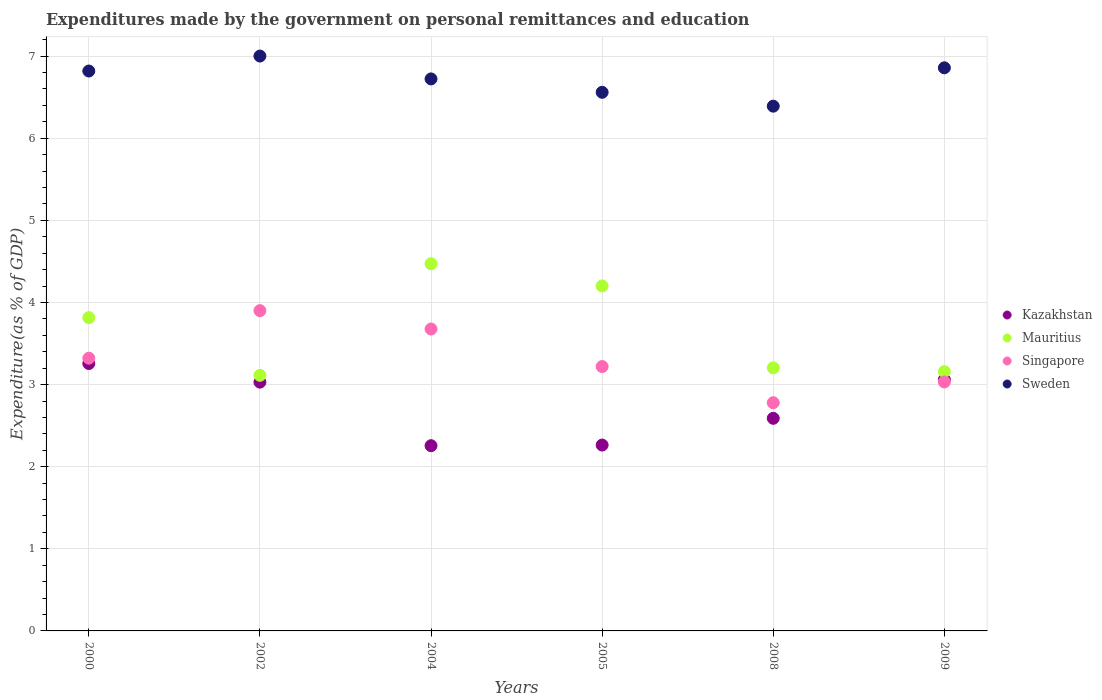What is the expenditures made by the government on personal remittances and education in Singapore in 2008?
Your answer should be compact. 2.78. Across all years, what is the maximum expenditures made by the government on personal remittances and education in Mauritius?
Provide a short and direct response. 4.47. Across all years, what is the minimum expenditures made by the government on personal remittances and education in Mauritius?
Give a very brief answer. 3.11. In which year was the expenditures made by the government on personal remittances and education in Singapore minimum?
Keep it short and to the point. 2008. What is the total expenditures made by the government on personal remittances and education in Mauritius in the graph?
Your answer should be compact. 21.96. What is the difference between the expenditures made by the government on personal remittances and education in Kazakhstan in 2004 and that in 2008?
Your answer should be very brief. -0.33. What is the difference between the expenditures made by the government on personal remittances and education in Kazakhstan in 2004 and the expenditures made by the government on personal remittances and education in Sweden in 2005?
Your answer should be very brief. -4.3. What is the average expenditures made by the government on personal remittances and education in Mauritius per year?
Keep it short and to the point. 3.66. In the year 2005, what is the difference between the expenditures made by the government on personal remittances and education in Singapore and expenditures made by the government on personal remittances and education in Kazakhstan?
Provide a short and direct response. 0.96. What is the ratio of the expenditures made by the government on personal remittances and education in Singapore in 2000 to that in 2009?
Your answer should be very brief. 1.1. What is the difference between the highest and the second highest expenditures made by the government on personal remittances and education in Kazakhstan?
Your answer should be very brief. 0.2. What is the difference between the highest and the lowest expenditures made by the government on personal remittances and education in Singapore?
Your response must be concise. 1.12. Does the expenditures made by the government on personal remittances and education in Singapore monotonically increase over the years?
Provide a succinct answer. No. Is the expenditures made by the government on personal remittances and education in Kazakhstan strictly less than the expenditures made by the government on personal remittances and education in Sweden over the years?
Your answer should be compact. Yes. How many dotlines are there?
Your answer should be very brief. 4. What is the difference between two consecutive major ticks on the Y-axis?
Your answer should be compact. 1. Are the values on the major ticks of Y-axis written in scientific E-notation?
Ensure brevity in your answer.  No. What is the title of the graph?
Provide a short and direct response. Expenditures made by the government on personal remittances and education. Does "Serbia" appear as one of the legend labels in the graph?
Your response must be concise. No. What is the label or title of the X-axis?
Your answer should be compact. Years. What is the label or title of the Y-axis?
Offer a very short reply. Expenditure(as % of GDP). What is the Expenditure(as % of GDP) in Kazakhstan in 2000?
Your answer should be compact. 3.26. What is the Expenditure(as % of GDP) in Mauritius in 2000?
Your response must be concise. 3.82. What is the Expenditure(as % of GDP) in Singapore in 2000?
Give a very brief answer. 3.32. What is the Expenditure(as % of GDP) in Sweden in 2000?
Your response must be concise. 6.82. What is the Expenditure(as % of GDP) in Kazakhstan in 2002?
Offer a terse response. 3.03. What is the Expenditure(as % of GDP) in Mauritius in 2002?
Make the answer very short. 3.11. What is the Expenditure(as % of GDP) in Singapore in 2002?
Offer a terse response. 3.9. What is the Expenditure(as % of GDP) in Sweden in 2002?
Your answer should be compact. 7. What is the Expenditure(as % of GDP) of Kazakhstan in 2004?
Your answer should be compact. 2.26. What is the Expenditure(as % of GDP) in Mauritius in 2004?
Give a very brief answer. 4.47. What is the Expenditure(as % of GDP) of Singapore in 2004?
Offer a very short reply. 3.68. What is the Expenditure(as % of GDP) of Sweden in 2004?
Your answer should be very brief. 6.72. What is the Expenditure(as % of GDP) of Kazakhstan in 2005?
Give a very brief answer. 2.26. What is the Expenditure(as % of GDP) in Mauritius in 2005?
Keep it short and to the point. 4.2. What is the Expenditure(as % of GDP) in Singapore in 2005?
Provide a short and direct response. 3.22. What is the Expenditure(as % of GDP) of Sweden in 2005?
Offer a very short reply. 6.56. What is the Expenditure(as % of GDP) in Kazakhstan in 2008?
Keep it short and to the point. 2.59. What is the Expenditure(as % of GDP) of Mauritius in 2008?
Your response must be concise. 3.2. What is the Expenditure(as % of GDP) in Singapore in 2008?
Your answer should be very brief. 2.78. What is the Expenditure(as % of GDP) of Sweden in 2008?
Provide a succinct answer. 6.39. What is the Expenditure(as % of GDP) of Kazakhstan in 2009?
Offer a very short reply. 3.06. What is the Expenditure(as % of GDP) of Mauritius in 2009?
Make the answer very short. 3.16. What is the Expenditure(as % of GDP) in Singapore in 2009?
Provide a succinct answer. 3.03. What is the Expenditure(as % of GDP) of Sweden in 2009?
Your answer should be compact. 6.86. Across all years, what is the maximum Expenditure(as % of GDP) of Kazakhstan?
Offer a very short reply. 3.26. Across all years, what is the maximum Expenditure(as % of GDP) of Mauritius?
Your response must be concise. 4.47. Across all years, what is the maximum Expenditure(as % of GDP) in Singapore?
Provide a succinct answer. 3.9. Across all years, what is the maximum Expenditure(as % of GDP) of Sweden?
Your answer should be very brief. 7. Across all years, what is the minimum Expenditure(as % of GDP) in Kazakhstan?
Ensure brevity in your answer.  2.26. Across all years, what is the minimum Expenditure(as % of GDP) in Mauritius?
Ensure brevity in your answer.  3.11. Across all years, what is the minimum Expenditure(as % of GDP) of Singapore?
Ensure brevity in your answer.  2.78. Across all years, what is the minimum Expenditure(as % of GDP) in Sweden?
Your answer should be compact. 6.39. What is the total Expenditure(as % of GDP) of Kazakhstan in the graph?
Your answer should be compact. 16.46. What is the total Expenditure(as % of GDP) in Mauritius in the graph?
Offer a very short reply. 21.96. What is the total Expenditure(as % of GDP) of Singapore in the graph?
Your answer should be compact. 19.93. What is the total Expenditure(as % of GDP) of Sweden in the graph?
Provide a succinct answer. 40.35. What is the difference between the Expenditure(as % of GDP) of Kazakhstan in 2000 and that in 2002?
Your answer should be very brief. 0.23. What is the difference between the Expenditure(as % of GDP) in Mauritius in 2000 and that in 2002?
Provide a succinct answer. 0.7. What is the difference between the Expenditure(as % of GDP) in Singapore in 2000 and that in 2002?
Provide a short and direct response. -0.58. What is the difference between the Expenditure(as % of GDP) of Sweden in 2000 and that in 2002?
Keep it short and to the point. -0.18. What is the difference between the Expenditure(as % of GDP) in Kazakhstan in 2000 and that in 2004?
Your answer should be very brief. 1. What is the difference between the Expenditure(as % of GDP) of Mauritius in 2000 and that in 2004?
Give a very brief answer. -0.66. What is the difference between the Expenditure(as % of GDP) of Singapore in 2000 and that in 2004?
Your answer should be very brief. -0.36. What is the difference between the Expenditure(as % of GDP) in Sweden in 2000 and that in 2004?
Your answer should be compact. 0.1. What is the difference between the Expenditure(as % of GDP) in Kazakhstan in 2000 and that in 2005?
Make the answer very short. 0.99. What is the difference between the Expenditure(as % of GDP) of Mauritius in 2000 and that in 2005?
Your response must be concise. -0.39. What is the difference between the Expenditure(as % of GDP) of Singapore in 2000 and that in 2005?
Your response must be concise. 0.1. What is the difference between the Expenditure(as % of GDP) of Sweden in 2000 and that in 2005?
Keep it short and to the point. 0.26. What is the difference between the Expenditure(as % of GDP) in Kazakhstan in 2000 and that in 2008?
Ensure brevity in your answer.  0.67. What is the difference between the Expenditure(as % of GDP) in Mauritius in 2000 and that in 2008?
Ensure brevity in your answer.  0.61. What is the difference between the Expenditure(as % of GDP) of Singapore in 2000 and that in 2008?
Offer a terse response. 0.54. What is the difference between the Expenditure(as % of GDP) of Sweden in 2000 and that in 2008?
Make the answer very short. 0.43. What is the difference between the Expenditure(as % of GDP) of Kazakhstan in 2000 and that in 2009?
Your answer should be very brief. 0.2. What is the difference between the Expenditure(as % of GDP) of Mauritius in 2000 and that in 2009?
Your answer should be very brief. 0.66. What is the difference between the Expenditure(as % of GDP) of Singapore in 2000 and that in 2009?
Provide a succinct answer. 0.29. What is the difference between the Expenditure(as % of GDP) in Sweden in 2000 and that in 2009?
Ensure brevity in your answer.  -0.04. What is the difference between the Expenditure(as % of GDP) in Kazakhstan in 2002 and that in 2004?
Your response must be concise. 0.77. What is the difference between the Expenditure(as % of GDP) in Mauritius in 2002 and that in 2004?
Provide a succinct answer. -1.36. What is the difference between the Expenditure(as % of GDP) in Singapore in 2002 and that in 2004?
Your answer should be compact. 0.22. What is the difference between the Expenditure(as % of GDP) in Sweden in 2002 and that in 2004?
Offer a terse response. 0.28. What is the difference between the Expenditure(as % of GDP) in Kazakhstan in 2002 and that in 2005?
Make the answer very short. 0.77. What is the difference between the Expenditure(as % of GDP) of Mauritius in 2002 and that in 2005?
Provide a succinct answer. -1.09. What is the difference between the Expenditure(as % of GDP) in Singapore in 2002 and that in 2005?
Your answer should be compact. 0.68. What is the difference between the Expenditure(as % of GDP) in Sweden in 2002 and that in 2005?
Make the answer very short. 0.44. What is the difference between the Expenditure(as % of GDP) of Kazakhstan in 2002 and that in 2008?
Make the answer very short. 0.44. What is the difference between the Expenditure(as % of GDP) of Mauritius in 2002 and that in 2008?
Your response must be concise. -0.09. What is the difference between the Expenditure(as % of GDP) in Singapore in 2002 and that in 2008?
Your answer should be compact. 1.12. What is the difference between the Expenditure(as % of GDP) of Sweden in 2002 and that in 2008?
Your answer should be very brief. 0.61. What is the difference between the Expenditure(as % of GDP) of Kazakhstan in 2002 and that in 2009?
Provide a succinct answer. -0.03. What is the difference between the Expenditure(as % of GDP) in Mauritius in 2002 and that in 2009?
Provide a short and direct response. -0.04. What is the difference between the Expenditure(as % of GDP) in Singapore in 2002 and that in 2009?
Provide a succinct answer. 0.87. What is the difference between the Expenditure(as % of GDP) in Sweden in 2002 and that in 2009?
Provide a succinct answer. 0.14. What is the difference between the Expenditure(as % of GDP) in Kazakhstan in 2004 and that in 2005?
Offer a terse response. -0.01. What is the difference between the Expenditure(as % of GDP) in Mauritius in 2004 and that in 2005?
Keep it short and to the point. 0.27. What is the difference between the Expenditure(as % of GDP) of Singapore in 2004 and that in 2005?
Keep it short and to the point. 0.46. What is the difference between the Expenditure(as % of GDP) of Sweden in 2004 and that in 2005?
Provide a short and direct response. 0.16. What is the difference between the Expenditure(as % of GDP) in Kazakhstan in 2004 and that in 2008?
Offer a very short reply. -0.33. What is the difference between the Expenditure(as % of GDP) of Mauritius in 2004 and that in 2008?
Provide a succinct answer. 1.27. What is the difference between the Expenditure(as % of GDP) of Singapore in 2004 and that in 2008?
Keep it short and to the point. 0.9. What is the difference between the Expenditure(as % of GDP) in Sweden in 2004 and that in 2008?
Give a very brief answer. 0.33. What is the difference between the Expenditure(as % of GDP) of Kazakhstan in 2004 and that in 2009?
Provide a succinct answer. -0.8. What is the difference between the Expenditure(as % of GDP) in Mauritius in 2004 and that in 2009?
Your answer should be compact. 1.31. What is the difference between the Expenditure(as % of GDP) of Singapore in 2004 and that in 2009?
Your answer should be very brief. 0.65. What is the difference between the Expenditure(as % of GDP) of Sweden in 2004 and that in 2009?
Your response must be concise. -0.14. What is the difference between the Expenditure(as % of GDP) of Kazakhstan in 2005 and that in 2008?
Offer a very short reply. -0.33. What is the difference between the Expenditure(as % of GDP) in Singapore in 2005 and that in 2008?
Keep it short and to the point. 0.44. What is the difference between the Expenditure(as % of GDP) of Sweden in 2005 and that in 2008?
Offer a very short reply. 0.17. What is the difference between the Expenditure(as % of GDP) of Kazakhstan in 2005 and that in 2009?
Your answer should be very brief. -0.8. What is the difference between the Expenditure(as % of GDP) of Mauritius in 2005 and that in 2009?
Ensure brevity in your answer.  1.04. What is the difference between the Expenditure(as % of GDP) of Singapore in 2005 and that in 2009?
Provide a short and direct response. 0.19. What is the difference between the Expenditure(as % of GDP) of Sweden in 2005 and that in 2009?
Provide a short and direct response. -0.3. What is the difference between the Expenditure(as % of GDP) in Kazakhstan in 2008 and that in 2009?
Your response must be concise. -0.47. What is the difference between the Expenditure(as % of GDP) in Mauritius in 2008 and that in 2009?
Your answer should be very brief. 0.05. What is the difference between the Expenditure(as % of GDP) in Singapore in 2008 and that in 2009?
Make the answer very short. -0.25. What is the difference between the Expenditure(as % of GDP) in Sweden in 2008 and that in 2009?
Offer a very short reply. -0.47. What is the difference between the Expenditure(as % of GDP) in Kazakhstan in 2000 and the Expenditure(as % of GDP) in Mauritius in 2002?
Offer a terse response. 0.14. What is the difference between the Expenditure(as % of GDP) of Kazakhstan in 2000 and the Expenditure(as % of GDP) of Singapore in 2002?
Offer a very short reply. -0.64. What is the difference between the Expenditure(as % of GDP) in Kazakhstan in 2000 and the Expenditure(as % of GDP) in Sweden in 2002?
Your answer should be very brief. -3.74. What is the difference between the Expenditure(as % of GDP) of Mauritius in 2000 and the Expenditure(as % of GDP) of Singapore in 2002?
Your response must be concise. -0.09. What is the difference between the Expenditure(as % of GDP) of Mauritius in 2000 and the Expenditure(as % of GDP) of Sweden in 2002?
Provide a succinct answer. -3.19. What is the difference between the Expenditure(as % of GDP) in Singapore in 2000 and the Expenditure(as % of GDP) in Sweden in 2002?
Ensure brevity in your answer.  -3.68. What is the difference between the Expenditure(as % of GDP) of Kazakhstan in 2000 and the Expenditure(as % of GDP) of Mauritius in 2004?
Provide a succinct answer. -1.22. What is the difference between the Expenditure(as % of GDP) in Kazakhstan in 2000 and the Expenditure(as % of GDP) in Singapore in 2004?
Your response must be concise. -0.42. What is the difference between the Expenditure(as % of GDP) of Kazakhstan in 2000 and the Expenditure(as % of GDP) of Sweden in 2004?
Provide a succinct answer. -3.47. What is the difference between the Expenditure(as % of GDP) of Mauritius in 2000 and the Expenditure(as % of GDP) of Singapore in 2004?
Offer a very short reply. 0.14. What is the difference between the Expenditure(as % of GDP) of Mauritius in 2000 and the Expenditure(as % of GDP) of Sweden in 2004?
Your response must be concise. -2.91. What is the difference between the Expenditure(as % of GDP) of Singapore in 2000 and the Expenditure(as % of GDP) of Sweden in 2004?
Give a very brief answer. -3.4. What is the difference between the Expenditure(as % of GDP) of Kazakhstan in 2000 and the Expenditure(as % of GDP) of Mauritius in 2005?
Your answer should be very brief. -0.94. What is the difference between the Expenditure(as % of GDP) in Kazakhstan in 2000 and the Expenditure(as % of GDP) in Singapore in 2005?
Your answer should be very brief. 0.04. What is the difference between the Expenditure(as % of GDP) of Kazakhstan in 2000 and the Expenditure(as % of GDP) of Sweden in 2005?
Keep it short and to the point. -3.3. What is the difference between the Expenditure(as % of GDP) of Mauritius in 2000 and the Expenditure(as % of GDP) of Singapore in 2005?
Provide a short and direct response. 0.6. What is the difference between the Expenditure(as % of GDP) in Mauritius in 2000 and the Expenditure(as % of GDP) in Sweden in 2005?
Keep it short and to the point. -2.74. What is the difference between the Expenditure(as % of GDP) of Singapore in 2000 and the Expenditure(as % of GDP) of Sweden in 2005?
Make the answer very short. -3.24. What is the difference between the Expenditure(as % of GDP) of Kazakhstan in 2000 and the Expenditure(as % of GDP) of Mauritius in 2008?
Provide a short and direct response. 0.05. What is the difference between the Expenditure(as % of GDP) of Kazakhstan in 2000 and the Expenditure(as % of GDP) of Singapore in 2008?
Your response must be concise. 0.48. What is the difference between the Expenditure(as % of GDP) in Kazakhstan in 2000 and the Expenditure(as % of GDP) in Sweden in 2008?
Your answer should be very brief. -3.13. What is the difference between the Expenditure(as % of GDP) of Mauritius in 2000 and the Expenditure(as % of GDP) of Singapore in 2008?
Ensure brevity in your answer.  1.04. What is the difference between the Expenditure(as % of GDP) in Mauritius in 2000 and the Expenditure(as % of GDP) in Sweden in 2008?
Provide a succinct answer. -2.58. What is the difference between the Expenditure(as % of GDP) in Singapore in 2000 and the Expenditure(as % of GDP) in Sweden in 2008?
Offer a terse response. -3.07. What is the difference between the Expenditure(as % of GDP) of Kazakhstan in 2000 and the Expenditure(as % of GDP) of Mauritius in 2009?
Provide a succinct answer. 0.1. What is the difference between the Expenditure(as % of GDP) of Kazakhstan in 2000 and the Expenditure(as % of GDP) of Singapore in 2009?
Ensure brevity in your answer.  0.22. What is the difference between the Expenditure(as % of GDP) of Kazakhstan in 2000 and the Expenditure(as % of GDP) of Sweden in 2009?
Your answer should be very brief. -3.6. What is the difference between the Expenditure(as % of GDP) in Mauritius in 2000 and the Expenditure(as % of GDP) in Singapore in 2009?
Make the answer very short. 0.78. What is the difference between the Expenditure(as % of GDP) of Mauritius in 2000 and the Expenditure(as % of GDP) of Sweden in 2009?
Provide a short and direct response. -3.04. What is the difference between the Expenditure(as % of GDP) in Singapore in 2000 and the Expenditure(as % of GDP) in Sweden in 2009?
Provide a succinct answer. -3.54. What is the difference between the Expenditure(as % of GDP) in Kazakhstan in 2002 and the Expenditure(as % of GDP) in Mauritius in 2004?
Provide a succinct answer. -1.44. What is the difference between the Expenditure(as % of GDP) in Kazakhstan in 2002 and the Expenditure(as % of GDP) in Singapore in 2004?
Provide a succinct answer. -0.65. What is the difference between the Expenditure(as % of GDP) of Kazakhstan in 2002 and the Expenditure(as % of GDP) of Sweden in 2004?
Ensure brevity in your answer.  -3.69. What is the difference between the Expenditure(as % of GDP) of Mauritius in 2002 and the Expenditure(as % of GDP) of Singapore in 2004?
Your answer should be compact. -0.56. What is the difference between the Expenditure(as % of GDP) in Mauritius in 2002 and the Expenditure(as % of GDP) in Sweden in 2004?
Make the answer very short. -3.61. What is the difference between the Expenditure(as % of GDP) in Singapore in 2002 and the Expenditure(as % of GDP) in Sweden in 2004?
Your response must be concise. -2.82. What is the difference between the Expenditure(as % of GDP) in Kazakhstan in 2002 and the Expenditure(as % of GDP) in Mauritius in 2005?
Offer a very short reply. -1.17. What is the difference between the Expenditure(as % of GDP) of Kazakhstan in 2002 and the Expenditure(as % of GDP) of Singapore in 2005?
Offer a terse response. -0.19. What is the difference between the Expenditure(as % of GDP) in Kazakhstan in 2002 and the Expenditure(as % of GDP) in Sweden in 2005?
Your answer should be compact. -3.53. What is the difference between the Expenditure(as % of GDP) in Mauritius in 2002 and the Expenditure(as % of GDP) in Singapore in 2005?
Provide a short and direct response. -0.11. What is the difference between the Expenditure(as % of GDP) in Mauritius in 2002 and the Expenditure(as % of GDP) in Sweden in 2005?
Give a very brief answer. -3.45. What is the difference between the Expenditure(as % of GDP) of Singapore in 2002 and the Expenditure(as % of GDP) of Sweden in 2005?
Your response must be concise. -2.66. What is the difference between the Expenditure(as % of GDP) in Kazakhstan in 2002 and the Expenditure(as % of GDP) in Mauritius in 2008?
Give a very brief answer. -0.17. What is the difference between the Expenditure(as % of GDP) of Kazakhstan in 2002 and the Expenditure(as % of GDP) of Singapore in 2008?
Offer a terse response. 0.25. What is the difference between the Expenditure(as % of GDP) in Kazakhstan in 2002 and the Expenditure(as % of GDP) in Sweden in 2008?
Ensure brevity in your answer.  -3.36. What is the difference between the Expenditure(as % of GDP) in Mauritius in 2002 and the Expenditure(as % of GDP) in Singapore in 2008?
Your answer should be compact. 0.33. What is the difference between the Expenditure(as % of GDP) in Mauritius in 2002 and the Expenditure(as % of GDP) in Sweden in 2008?
Your response must be concise. -3.28. What is the difference between the Expenditure(as % of GDP) in Singapore in 2002 and the Expenditure(as % of GDP) in Sweden in 2008?
Your answer should be very brief. -2.49. What is the difference between the Expenditure(as % of GDP) of Kazakhstan in 2002 and the Expenditure(as % of GDP) of Mauritius in 2009?
Ensure brevity in your answer.  -0.13. What is the difference between the Expenditure(as % of GDP) in Kazakhstan in 2002 and the Expenditure(as % of GDP) in Singapore in 2009?
Provide a short and direct response. -0. What is the difference between the Expenditure(as % of GDP) of Kazakhstan in 2002 and the Expenditure(as % of GDP) of Sweden in 2009?
Offer a very short reply. -3.83. What is the difference between the Expenditure(as % of GDP) in Mauritius in 2002 and the Expenditure(as % of GDP) in Singapore in 2009?
Your response must be concise. 0.08. What is the difference between the Expenditure(as % of GDP) in Mauritius in 2002 and the Expenditure(as % of GDP) in Sweden in 2009?
Make the answer very short. -3.74. What is the difference between the Expenditure(as % of GDP) of Singapore in 2002 and the Expenditure(as % of GDP) of Sweden in 2009?
Provide a succinct answer. -2.96. What is the difference between the Expenditure(as % of GDP) of Kazakhstan in 2004 and the Expenditure(as % of GDP) of Mauritius in 2005?
Your response must be concise. -1.95. What is the difference between the Expenditure(as % of GDP) in Kazakhstan in 2004 and the Expenditure(as % of GDP) in Singapore in 2005?
Your answer should be compact. -0.96. What is the difference between the Expenditure(as % of GDP) of Kazakhstan in 2004 and the Expenditure(as % of GDP) of Sweden in 2005?
Your response must be concise. -4.3. What is the difference between the Expenditure(as % of GDP) of Mauritius in 2004 and the Expenditure(as % of GDP) of Singapore in 2005?
Make the answer very short. 1.25. What is the difference between the Expenditure(as % of GDP) in Mauritius in 2004 and the Expenditure(as % of GDP) in Sweden in 2005?
Keep it short and to the point. -2.09. What is the difference between the Expenditure(as % of GDP) of Singapore in 2004 and the Expenditure(as % of GDP) of Sweden in 2005?
Keep it short and to the point. -2.88. What is the difference between the Expenditure(as % of GDP) of Kazakhstan in 2004 and the Expenditure(as % of GDP) of Mauritius in 2008?
Offer a terse response. -0.95. What is the difference between the Expenditure(as % of GDP) in Kazakhstan in 2004 and the Expenditure(as % of GDP) in Singapore in 2008?
Offer a very short reply. -0.52. What is the difference between the Expenditure(as % of GDP) of Kazakhstan in 2004 and the Expenditure(as % of GDP) of Sweden in 2008?
Offer a terse response. -4.13. What is the difference between the Expenditure(as % of GDP) in Mauritius in 2004 and the Expenditure(as % of GDP) in Singapore in 2008?
Keep it short and to the point. 1.69. What is the difference between the Expenditure(as % of GDP) in Mauritius in 2004 and the Expenditure(as % of GDP) in Sweden in 2008?
Provide a succinct answer. -1.92. What is the difference between the Expenditure(as % of GDP) in Singapore in 2004 and the Expenditure(as % of GDP) in Sweden in 2008?
Offer a terse response. -2.71. What is the difference between the Expenditure(as % of GDP) in Kazakhstan in 2004 and the Expenditure(as % of GDP) in Mauritius in 2009?
Give a very brief answer. -0.9. What is the difference between the Expenditure(as % of GDP) in Kazakhstan in 2004 and the Expenditure(as % of GDP) in Singapore in 2009?
Provide a short and direct response. -0.78. What is the difference between the Expenditure(as % of GDP) in Kazakhstan in 2004 and the Expenditure(as % of GDP) in Sweden in 2009?
Ensure brevity in your answer.  -4.6. What is the difference between the Expenditure(as % of GDP) in Mauritius in 2004 and the Expenditure(as % of GDP) in Singapore in 2009?
Give a very brief answer. 1.44. What is the difference between the Expenditure(as % of GDP) of Mauritius in 2004 and the Expenditure(as % of GDP) of Sweden in 2009?
Offer a terse response. -2.39. What is the difference between the Expenditure(as % of GDP) of Singapore in 2004 and the Expenditure(as % of GDP) of Sweden in 2009?
Your answer should be very brief. -3.18. What is the difference between the Expenditure(as % of GDP) in Kazakhstan in 2005 and the Expenditure(as % of GDP) in Mauritius in 2008?
Give a very brief answer. -0.94. What is the difference between the Expenditure(as % of GDP) of Kazakhstan in 2005 and the Expenditure(as % of GDP) of Singapore in 2008?
Provide a short and direct response. -0.52. What is the difference between the Expenditure(as % of GDP) in Kazakhstan in 2005 and the Expenditure(as % of GDP) in Sweden in 2008?
Provide a succinct answer. -4.13. What is the difference between the Expenditure(as % of GDP) of Mauritius in 2005 and the Expenditure(as % of GDP) of Singapore in 2008?
Make the answer very short. 1.42. What is the difference between the Expenditure(as % of GDP) of Mauritius in 2005 and the Expenditure(as % of GDP) of Sweden in 2008?
Your answer should be very brief. -2.19. What is the difference between the Expenditure(as % of GDP) in Singapore in 2005 and the Expenditure(as % of GDP) in Sweden in 2008?
Provide a short and direct response. -3.17. What is the difference between the Expenditure(as % of GDP) of Kazakhstan in 2005 and the Expenditure(as % of GDP) of Mauritius in 2009?
Make the answer very short. -0.89. What is the difference between the Expenditure(as % of GDP) of Kazakhstan in 2005 and the Expenditure(as % of GDP) of Singapore in 2009?
Make the answer very short. -0.77. What is the difference between the Expenditure(as % of GDP) of Kazakhstan in 2005 and the Expenditure(as % of GDP) of Sweden in 2009?
Your answer should be compact. -4.59. What is the difference between the Expenditure(as % of GDP) of Mauritius in 2005 and the Expenditure(as % of GDP) of Singapore in 2009?
Your answer should be compact. 1.17. What is the difference between the Expenditure(as % of GDP) of Mauritius in 2005 and the Expenditure(as % of GDP) of Sweden in 2009?
Offer a terse response. -2.66. What is the difference between the Expenditure(as % of GDP) in Singapore in 2005 and the Expenditure(as % of GDP) in Sweden in 2009?
Your response must be concise. -3.64. What is the difference between the Expenditure(as % of GDP) in Kazakhstan in 2008 and the Expenditure(as % of GDP) in Mauritius in 2009?
Your answer should be very brief. -0.57. What is the difference between the Expenditure(as % of GDP) of Kazakhstan in 2008 and the Expenditure(as % of GDP) of Singapore in 2009?
Your answer should be compact. -0.44. What is the difference between the Expenditure(as % of GDP) in Kazakhstan in 2008 and the Expenditure(as % of GDP) in Sweden in 2009?
Offer a very short reply. -4.27. What is the difference between the Expenditure(as % of GDP) in Mauritius in 2008 and the Expenditure(as % of GDP) in Singapore in 2009?
Your answer should be very brief. 0.17. What is the difference between the Expenditure(as % of GDP) in Mauritius in 2008 and the Expenditure(as % of GDP) in Sweden in 2009?
Keep it short and to the point. -3.65. What is the difference between the Expenditure(as % of GDP) of Singapore in 2008 and the Expenditure(as % of GDP) of Sweden in 2009?
Give a very brief answer. -4.08. What is the average Expenditure(as % of GDP) in Kazakhstan per year?
Offer a very short reply. 2.74. What is the average Expenditure(as % of GDP) in Mauritius per year?
Ensure brevity in your answer.  3.66. What is the average Expenditure(as % of GDP) in Singapore per year?
Your answer should be compact. 3.32. What is the average Expenditure(as % of GDP) in Sweden per year?
Offer a very short reply. 6.73. In the year 2000, what is the difference between the Expenditure(as % of GDP) of Kazakhstan and Expenditure(as % of GDP) of Mauritius?
Offer a very short reply. -0.56. In the year 2000, what is the difference between the Expenditure(as % of GDP) in Kazakhstan and Expenditure(as % of GDP) in Singapore?
Offer a terse response. -0.06. In the year 2000, what is the difference between the Expenditure(as % of GDP) of Kazakhstan and Expenditure(as % of GDP) of Sweden?
Provide a succinct answer. -3.56. In the year 2000, what is the difference between the Expenditure(as % of GDP) in Mauritius and Expenditure(as % of GDP) in Singapore?
Provide a succinct answer. 0.49. In the year 2000, what is the difference between the Expenditure(as % of GDP) of Mauritius and Expenditure(as % of GDP) of Sweden?
Ensure brevity in your answer.  -3. In the year 2000, what is the difference between the Expenditure(as % of GDP) in Singapore and Expenditure(as % of GDP) in Sweden?
Provide a short and direct response. -3.5. In the year 2002, what is the difference between the Expenditure(as % of GDP) of Kazakhstan and Expenditure(as % of GDP) of Mauritius?
Keep it short and to the point. -0.08. In the year 2002, what is the difference between the Expenditure(as % of GDP) of Kazakhstan and Expenditure(as % of GDP) of Singapore?
Keep it short and to the point. -0.87. In the year 2002, what is the difference between the Expenditure(as % of GDP) in Kazakhstan and Expenditure(as % of GDP) in Sweden?
Provide a succinct answer. -3.97. In the year 2002, what is the difference between the Expenditure(as % of GDP) of Mauritius and Expenditure(as % of GDP) of Singapore?
Provide a succinct answer. -0.79. In the year 2002, what is the difference between the Expenditure(as % of GDP) in Mauritius and Expenditure(as % of GDP) in Sweden?
Your answer should be compact. -3.89. In the year 2002, what is the difference between the Expenditure(as % of GDP) of Singapore and Expenditure(as % of GDP) of Sweden?
Offer a very short reply. -3.1. In the year 2004, what is the difference between the Expenditure(as % of GDP) in Kazakhstan and Expenditure(as % of GDP) in Mauritius?
Your answer should be compact. -2.22. In the year 2004, what is the difference between the Expenditure(as % of GDP) in Kazakhstan and Expenditure(as % of GDP) in Singapore?
Provide a short and direct response. -1.42. In the year 2004, what is the difference between the Expenditure(as % of GDP) of Kazakhstan and Expenditure(as % of GDP) of Sweden?
Your response must be concise. -4.47. In the year 2004, what is the difference between the Expenditure(as % of GDP) in Mauritius and Expenditure(as % of GDP) in Singapore?
Provide a succinct answer. 0.8. In the year 2004, what is the difference between the Expenditure(as % of GDP) in Mauritius and Expenditure(as % of GDP) in Sweden?
Your answer should be compact. -2.25. In the year 2004, what is the difference between the Expenditure(as % of GDP) in Singapore and Expenditure(as % of GDP) in Sweden?
Your response must be concise. -3.05. In the year 2005, what is the difference between the Expenditure(as % of GDP) of Kazakhstan and Expenditure(as % of GDP) of Mauritius?
Ensure brevity in your answer.  -1.94. In the year 2005, what is the difference between the Expenditure(as % of GDP) in Kazakhstan and Expenditure(as % of GDP) in Singapore?
Offer a very short reply. -0.96. In the year 2005, what is the difference between the Expenditure(as % of GDP) of Kazakhstan and Expenditure(as % of GDP) of Sweden?
Keep it short and to the point. -4.3. In the year 2005, what is the difference between the Expenditure(as % of GDP) in Mauritius and Expenditure(as % of GDP) in Singapore?
Your answer should be very brief. 0.98. In the year 2005, what is the difference between the Expenditure(as % of GDP) in Mauritius and Expenditure(as % of GDP) in Sweden?
Your answer should be very brief. -2.36. In the year 2005, what is the difference between the Expenditure(as % of GDP) in Singapore and Expenditure(as % of GDP) in Sweden?
Your response must be concise. -3.34. In the year 2008, what is the difference between the Expenditure(as % of GDP) in Kazakhstan and Expenditure(as % of GDP) in Mauritius?
Your answer should be very brief. -0.61. In the year 2008, what is the difference between the Expenditure(as % of GDP) of Kazakhstan and Expenditure(as % of GDP) of Singapore?
Keep it short and to the point. -0.19. In the year 2008, what is the difference between the Expenditure(as % of GDP) of Kazakhstan and Expenditure(as % of GDP) of Sweden?
Provide a short and direct response. -3.8. In the year 2008, what is the difference between the Expenditure(as % of GDP) of Mauritius and Expenditure(as % of GDP) of Singapore?
Ensure brevity in your answer.  0.42. In the year 2008, what is the difference between the Expenditure(as % of GDP) in Mauritius and Expenditure(as % of GDP) in Sweden?
Give a very brief answer. -3.19. In the year 2008, what is the difference between the Expenditure(as % of GDP) in Singapore and Expenditure(as % of GDP) in Sweden?
Your answer should be very brief. -3.61. In the year 2009, what is the difference between the Expenditure(as % of GDP) in Kazakhstan and Expenditure(as % of GDP) in Mauritius?
Your response must be concise. -0.1. In the year 2009, what is the difference between the Expenditure(as % of GDP) of Kazakhstan and Expenditure(as % of GDP) of Singapore?
Ensure brevity in your answer.  0.03. In the year 2009, what is the difference between the Expenditure(as % of GDP) in Kazakhstan and Expenditure(as % of GDP) in Sweden?
Offer a terse response. -3.8. In the year 2009, what is the difference between the Expenditure(as % of GDP) in Mauritius and Expenditure(as % of GDP) in Singapore?
Provide a short and direct response. 0.13. In the year 2009, what is the difference between the Expenditure(as % of GDP) in Mauritius and Expenditure(as % of GDP) in Sweden?
Offer a very short reply. -3.7. In the year 2009, what is the difference between the Expenditure(as % of GDP) in Singapore and Expenditure(as % of GDP) in Sweden?
Offer a very short reply. -3.83. What is the ratio of the Expenditure(as % of GDP) in Kazakhstan in 2000 to that in 2002?
Keep it short and to the point. 1.07. What is the ratio of the Expenditure(as % of GDP) of Mauritius in 2000 to that in 2002?
Provide a short and direct response. 1.23. What is the ratio of the Expenditure(as % of GDP) in Singapore in 2000 to that in 2002?
Your answer should be compact. 0.85. What is the ratio of the Expenditure(as % of GDP) in Sweden in 2000 to that in 2002?
Make the answer very short. 0.97. What is the ratio of the Expenditure(as % of GDP) in Kazakhstan in 2000 to that in 2004?
Provide a succinct answer. 1.44. What is the ratio of the Expenditure(as % of GDP) in Mauritius in 2000 to that in 2004?
Keep it short and to the point. 0.85. What is the ratio of the Expenditure(as % of GDP) of Singapore in 2000 to that in 2004?
Keep it short and to the point. 0.9. What is the ratio of the Expenditure(as % of GDP) of Sweden in 2000 to that in 2004?
Keep it short and to the point. 1.01. What is the ratio of the Expenditure(as % of GDP) in Kazakhstan in 2000 to that in 2005?
Your answer should be compact. 1.44. What is the ratio of the Expenditure(as % of GDP) in Mauritius in 2000 to that in 2005?
Make the answer very short. 0.91. What is the ratio of the Expenditure(as % of GDP) of Singapore in 2000 to that in 2005?
Keep it short and to the point. 1.03. What is the ratio of the Expenditure(as % of GDP) of Sweden in 2000 to that in 2005?
Your answer should be very brief. 1.04. What is the ratio of the Expenditure(as % of GDP) in Kazakhstan in 2000 to that in 2008?
Keep it short and to the point. 1.26. What is the ratio of the Expenditure(as % of GDP) in Mauritius in 2000 to that in 2008?
Your answer should be very brief. 1.19. What is the ratio of the Expenditure(as % of GDP) of Singapore in 2000 to that in 2008?
Ensure brevity in your answer.  1.2. What is the ratio of the Expenditure(as % of GDP) of Sweden in 2000 to that in 2008?
Make the answer very short. 1.07. What is the ratio of the Expenditure(as % of GDP) in Kazakhstan in 2000 to that in 2009?
Make the answer very short. 1.06. What is the ratio of the Expenditure(as % of GDP) of Mauritius in 2000 to that in 2009?
Make the answer very short. 1.21. What is the ratio of the Expenditure(as % of GDP) of Singapore in 2000 to that in 2009?
Give a very brief answer. 1.1. What is the ratio of the Expenditure(as % of GDP) in Kazakhstan in 2002 to that in 2004?
Ensure brevity in your answer.  1.34. What is the ratio of the Expenditure(as % of GDP) in Mauritius in 2002 to that in 2004?
Your response must be concise. 0.7. What is the ratio of the Expenditure(as % of GDP) in Singapore in 2002 to that in 2004?
Your answer should be very brief. 1.06. What is the ratio of the Expenditure(as % of GDP) of Sweden in 2002 to that in 2004?
Ensure brevity in your answer.  1.04. What is the ratio of the Expenditure(as % of GDP) of Kazakhstan in 2002 to that in 2005?
Keep it short and to the point. 1.34. What is the ratio of the Expenditure(as % of GDP) of Mauritius in 2002 to that in 2005?
Offer a very short reply. 0.74. What is the ratio of the Expenditure(as % of GDP) of Singapore in 2002 to that in 2005?
Ensure brevity in your answer.  1.21. What is the ratio of the Expenditure(as % of GDP) in Sweden in 2002 to that in 2005?
Ensure brevity in your answer.  1.07. What is the ratio of the Expenditure(as % of GDP) in Kazakhstan in 2002 to that in 2008?
Provide a succinct answer. 1.17. What is the ratio of the Expenditure(as % of GDP) in Mauritius in 2002 to that in 2008?
Your answer should be very brief. 0.97. What is the ratio of the Expenditure(as % of GDP) in Singapore in 2002 to that in 2008?
Your answer should be compact. 1.4. What is the ratio of the Expenditure(as % of GDP) of Sweden in 2002 to that in 2008?
Your response must be concise. 1.1. What is the ratio of the Expenditure(as % of GDP) of Kazakhstan in 2002 to that in 2009?
Make the answer very short. 0.99. What is the ratio of the Expenditure(as % of GDP) in Mauritius in 2002 to that in 2009?
Offer a very short reply. 0.99. What is the ratio of the Expenditure(as % of GDP) in Singapore in 2002 to that in 2009?
Ensure brevity in your answer.  1.29. What is the ratio of the Expenditure(as % of GDP) in Sweden in 2002 to that in 2009?
Ensure brevity in your answer.  1.02. What is the ratio of the Expenditure(as % of GDP) of Mauritius in 2004 to that in 2005?
Offer a very short reply. 1.06. What is the ratio of the Expenditure(as % of GDP) in Singapore in 2004 to that in 2005?
Make the answer very short. 1.14. What is the ratio of the Expenditure(as % of GDP) of Sweden in 2004 to that in 2005?
Ensure brevity in your answer.  1.02. What is the ratio of the Expenditure(as % of GDP) in Kazakhstan in 2004 to that in 2008?
Provide a succinct answer. 0.87. What is the ratio of the Expenditure(as % of GDP) of Mauritius in 2004 to that in 2008?
Ensure brevity in your answer.  1.4. What is the ratio of the Expenditure(as % of GDP) of Singapore in 2004 to that in 2008?
Give a very brief answer. 1.32. What is the ratio of the Expenditure(as % of GDP) in Sweden in 2004 to that in 2008?
Offer a very short reply. 1.05. What is the ratio of the Expenditure(as % of GDP) of Kazakhstan in 2004 to that in 2009?
Your answer should be compact. 0.74. What is the ratio of the Expenditure(as % of GDP) of Mauritius in 2004 to that in 2009?
Your response must be concise. 1.42. What is the ratio of the Expenditure(as % of GDP) in Singapore in 2004 to that in 2009?
Your response must be concise. 1.21. What is the ratio of the Expenditure(as % of GDP) in Sweden in 2004 to that in 2009?
Your answer should be very brief. 0.98. What is the ratio of the Expenditure(as % of GDP) of Kazakhstan in 2005 to that in 2008?
Make the answer very short. 0.87. What is the ratio of the Expenditure(as % of GDP) of Mauritius in 2005 to that in 2008?
Your response must be concise. 1.31. What is the ratio of the Expenditure(as % of GDP) in Singapore in 2005 to that in 2008?
Offer a terse response. 1.16. What is the ratio of the Expenditure(as % of GDP) of Sweden in 2005 to that in 2008?
Your answer should be compact. 1.03. What is the ratio of the Expenditure(as % of GDP) of Kazakhstan in 2005 to that in 2009?
Give a very brief answer. 0.74. What is the ratio of the Expenditure(as % of GDP) in Mauritius in 2005 to that in 2009?
Offer a very short reply. 1.33. What is the ratio of the Expenditure(as % of GDP) in Singapore in 2005 to that in 2009?
Provide a succinct answer. 1.06. What is the ratio of the Expenditure(as % of GDP) of Sweden in 2005 to that in 2009?
Offer a very short reply. 0.96. What is the ratio of the Expenditure(as % of GDP) in Kazakhstan in 2008 to that in 2009?
Your answer should be very brief. 0.85. What is the ratio of the Expenditure(as % of GDP) in Mauritius in 2008 to that in 2009?
Provide a succinct answer. 1.01. What is the ratio of the Expenditure(as % of GDP) of Sweden in 2008 to that in 2009?
Your answer should be very brief. 0.93. What is the difference between the highest and the second highest Expenditure(as % of GDP) in Kazakhstan?
Ensure brevity in your answer.  0.2. What is the difference between the highest and the second highest Expenditure(as % of GDP) in Mauritius?
Ensure brevity in your answer.  0.27. What is the difference between the highest and the second highest Expenditure(as % of GDP) in Singapore?
Give a very brief answer. 0.22. What is the difference between the highest and the second highest Expenditure(as % of GDP) in Sweden?
Give a very brief answer. 0.14. What is the difference between the highest and the lowest Expenditure(as % of GDP) in Kazakhstan?
Provide a short and direct response. 1. What is the difference between the highest and the lowest Expenditure(as % of GDP) of Mauritius?
Offer a terse response. 1.36. What is the difference between the highest and the lowest Expenditure(as % of GDP) in Singapore?
Keep it short and to the point. 1.12. What is the difference between the highest and the lowest Expenditure(as % of GDP) of Sweden?
Give a very brief answer. 0.61. 